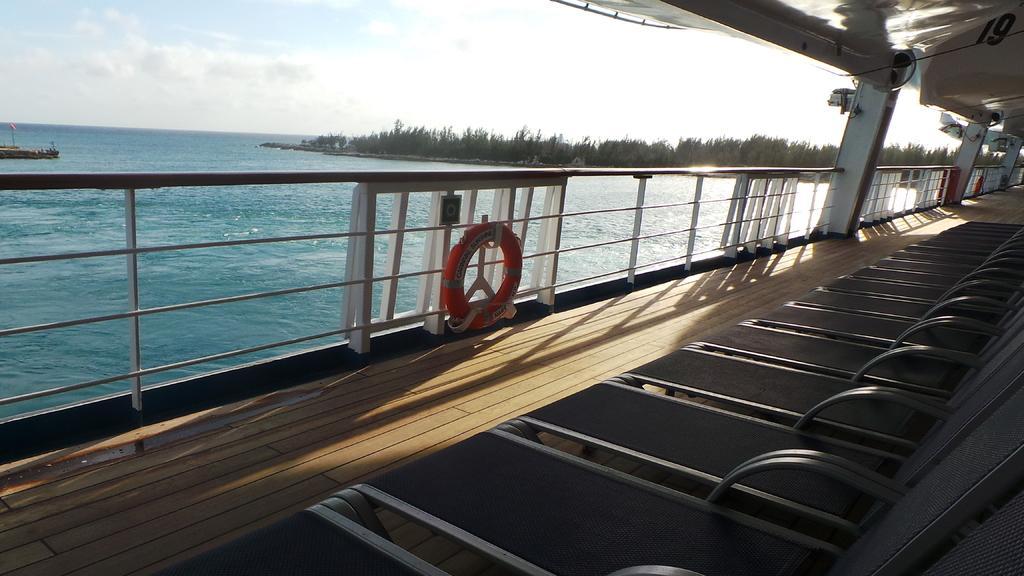Could you give a brief overview of what you see in this image? In this picture I can see inflatable safety tubes, chairs and fans in the ship, which is on the water, there is a boat on the water, there are trees, and in the background there is sky. 